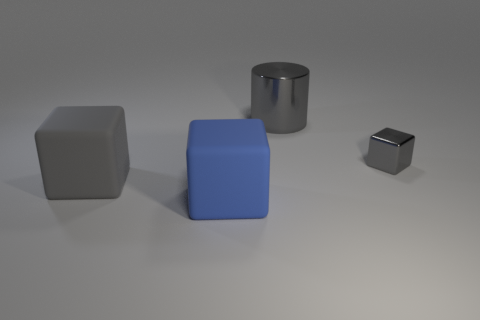Add 2 small gray shiny objects. How many objects exist? 6 Subtract all cubes. How many objects are left? 1 Add 4 small metal objects. How many small metal objects are left? 5 Add 3 tiny metallic objects. How many tiny metallic objects exist? 4 Subtract 0 red blocks. How many objects are left? 4 Subtract all small things. Subtract all cylinders. How many objects are left? 2 